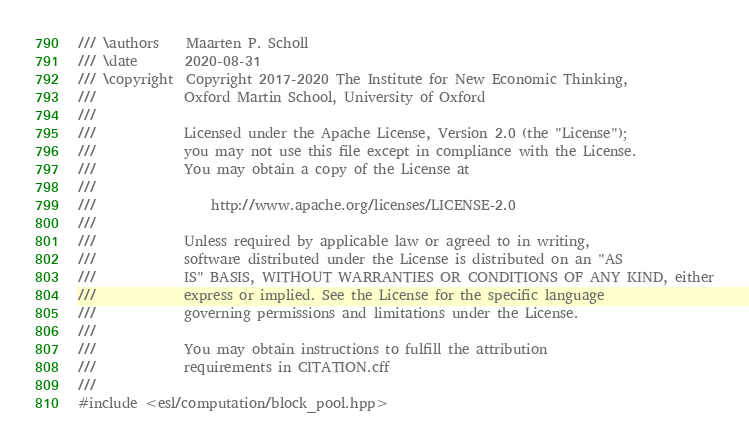Convert code to text. <code><loc_0><loc_0><loc_500><loc_500><_C++_>/// \authors    Maarten P. Scholl
/// \date       2020-08-31
/// \copyright  Copyright 2017-2020 The Institute for New Economic Thinking,
///             Oxford Martin School, University of Oxford
///
///             Licensed under the Apache License, Version 2.0 (the "License");
///             you may not use this file except in compliance with the License.
///             You may obtain a copy of the License at
///
///                 http://www.apache.org/licenses/LICENSE-2.0
///
///             Unless required by applicable law or agreed to in writing,
///             software distributed under the License is distributed on an "AS
///             IS" BASIS, WITHOUT WARRANTIES OR CONDITIONS OF ANY KIND, either
///             express or implied. See the License for the specific language
///             governing permissions and limitations under the License.
///
///             You may obtain instructions to fulfill the attribution
///             requirements in CITATION.cff
///
#include <esl/computation/block_pool.hpp></code> 